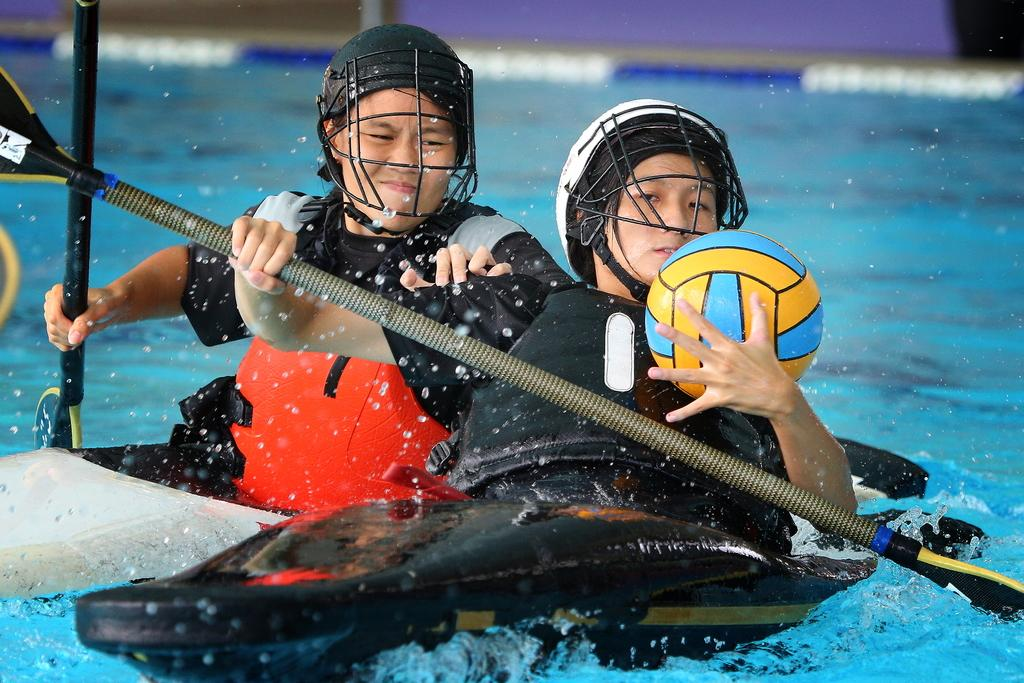How many people are in the image? There are two people in the image. What are the people doing in the image? The people are riding a boat in the water. What objects are the people holding in the image? The people are holding a shaft and a ball in their hands. Can you tell me how many toes the people are showing in the image? There is no information about the people's toes in the image, so it cannot be determined. 